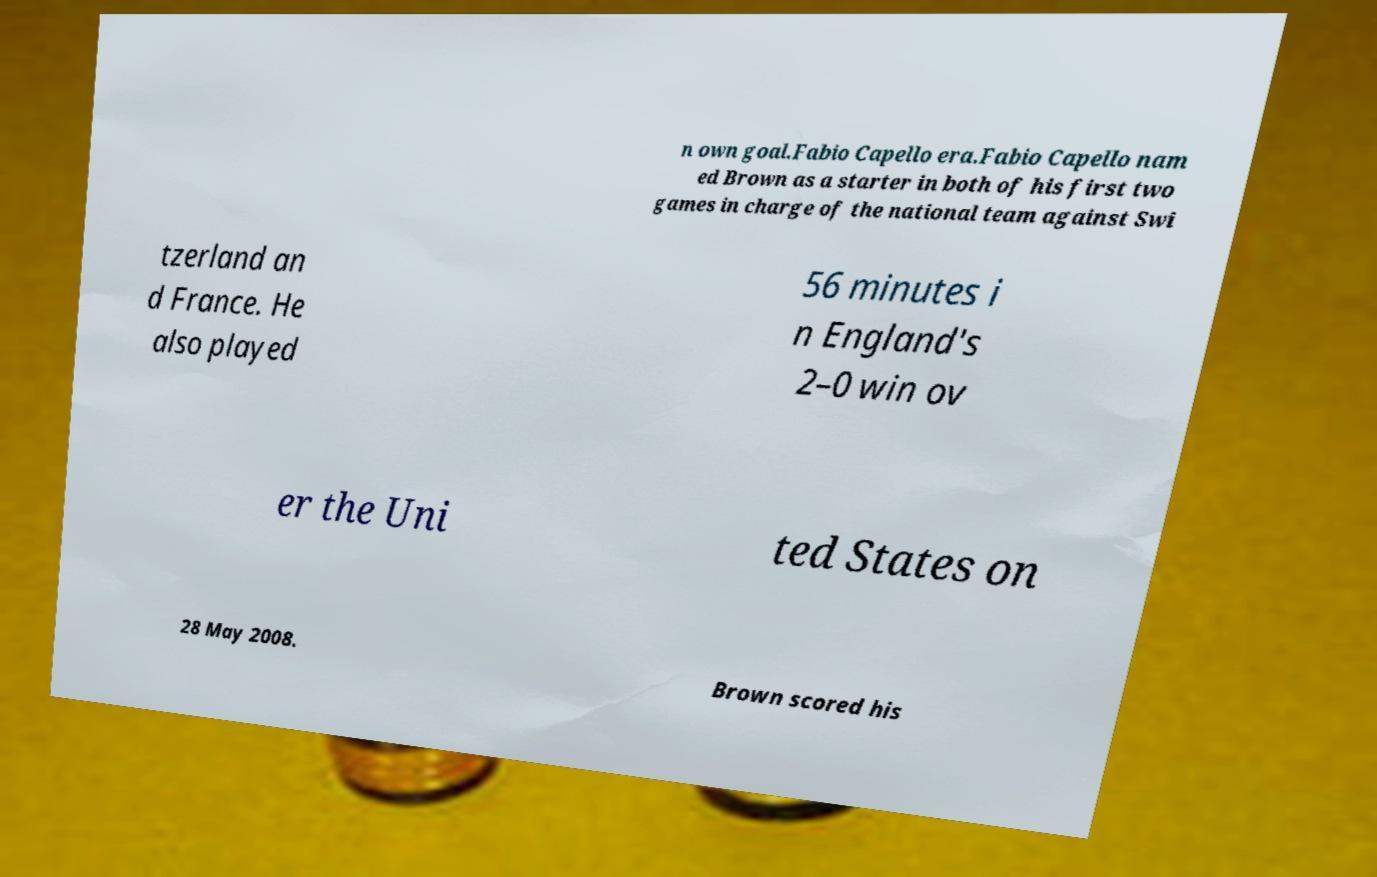Can you accurately transcribe the text from the provided image for me? n own goal.Fabio Capello era.Fabio Capello nam ed Brown as a starter in both of his first two games in charge of the national team against Swi tzerland an d France. He also played 56 minutes i n England's 2–0 win ov er the Uni ted States on 28 May 2008. Brown scored his 